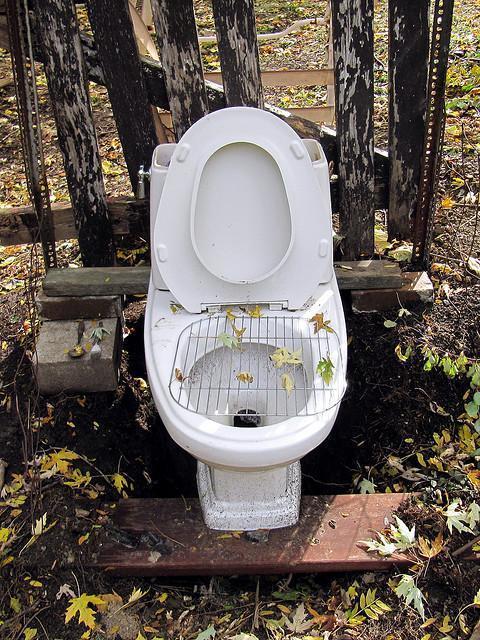How many people can be seen crossing the street?
Give a very brief answer. 0. 